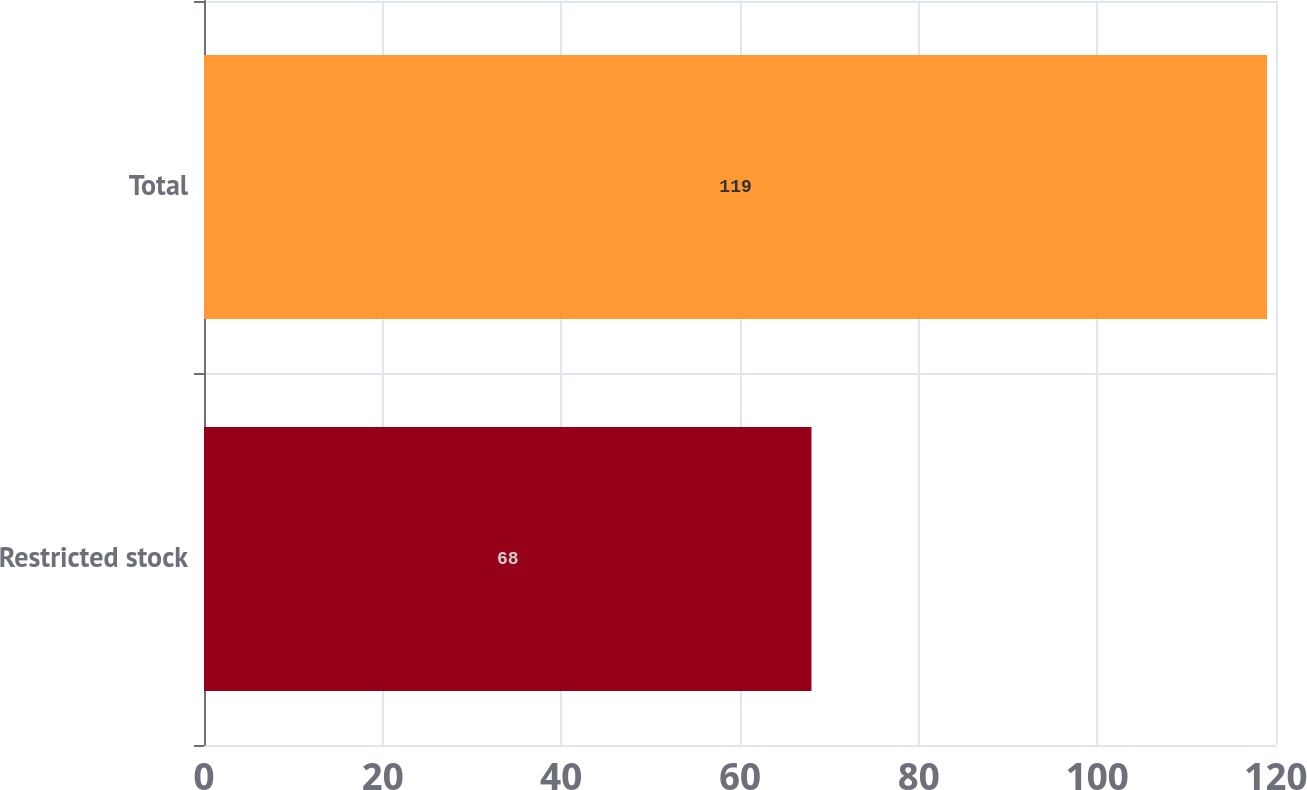Convert chart to OTSL. <chart><loc_0><loc_0><loc_500><loc_500><bar_chart><fcel>Restricted stock<fcel>Total<nl><fcel>68<fcel>119<nl></chart> 